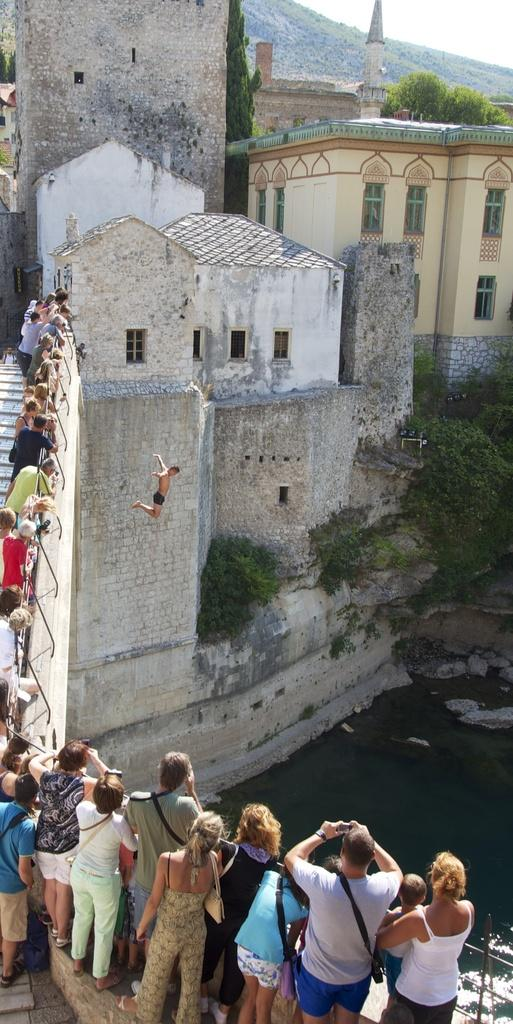How many people are in the group that is visible in the image? There is a group of people standing in the image, but the exact number cannot be determined from the provided facts. What type of structures can be seen in the image? There are buildings visible in the image. What is the person in the image doing? There is a person jumping in the image. What type of vegetation is present in the image? Trees are present in the image. What natural element is visible in the image? There is water visible in the image. What is visible at the top of the image? The sky is visible in the image. What type of glue is being used by the person jumping in the image? There is no glue present in the image, and the person jumping is not using any glue. How many toes are visible on the people in the image? The exact number of people in the image cannot be determined from the provided facts. 